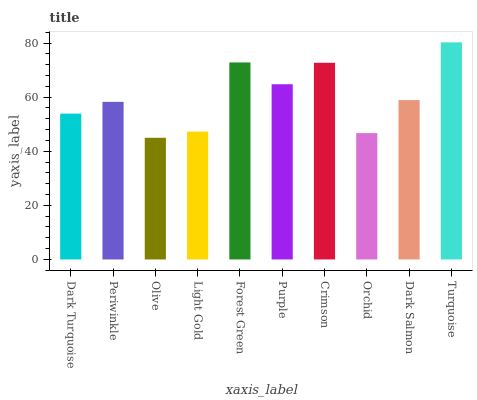Is Olive the minimum?
Answer yes or no. Yes. Is Turquoise the maximum?
Answer yes or no. Yes. Is Periwinkle the minimum?
Answer yes or no. No. Is Periwinkle the maximum?
Answer yes or no. No. Is Periwinkle greater than Dark Turquoise?
Answer yes or no. Yes. Is Dark Turquoise less than Periwinkle?
Answer yes or no. Yes. Is Dark Turquoise greater than Periwinkle?
Answer yes or no. No. Is Periwinkle less than Dark Turquoise?
Answer yes or no. No. Is Dark Salmon the high median?
Answer yes or no. Yes. Is Periwinkle the low median?
Answer yes or no. Yes. Is Periwinkle the high median?
Answer yes or no. No. Is Purple the low median?
Answer yes or no. No. 